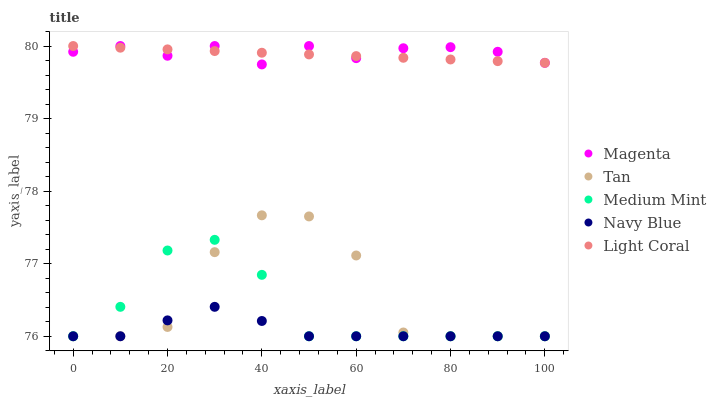Does Navy Blue have the minimum area under the curve?
Answer yes or no. Yes. Does Magenta have the maximum area under the curve?
Answer yes or no. Yes. Does Magenta have the minimum area under the curve?
Answer yes or no. No. Does Navy Blue have the maximum area under the curve?
Answer yes or no. No. Is Light Coral the smoothest?
Answer yes or no. Yes. Is Tan the roughest?
Answer yes or no. Yes. Is Navy Blue the smoothest?
Answer yes or no. No. Is Navy Blue the roughest?
Answer yes or no. No. Does Medium Mint have the lowest value?
Answer yes or no. Yes. Does Magenta have the lowest value?
Answer yes or no. No. Does Light Coral have the highest value?
Answer yes or no. Yes. Does Navy Blue have the highest value?
Answer yes or no. No. Is Medium Mint less than Light Coral?
Answer yes or no. Yes. Is Magenta greater than Medium Mint?
Answer yes or no. Yes. Does Tan intersect Medium Mint?
Answer yes or no. Yes. Is Tan less than Medium Mint?
Answer yes or no. No. Is Tan greater than Medium Mint?
Answer yes or no. No. Does Medium Mint intersect Light Coral?
Answer yes or no. No. 